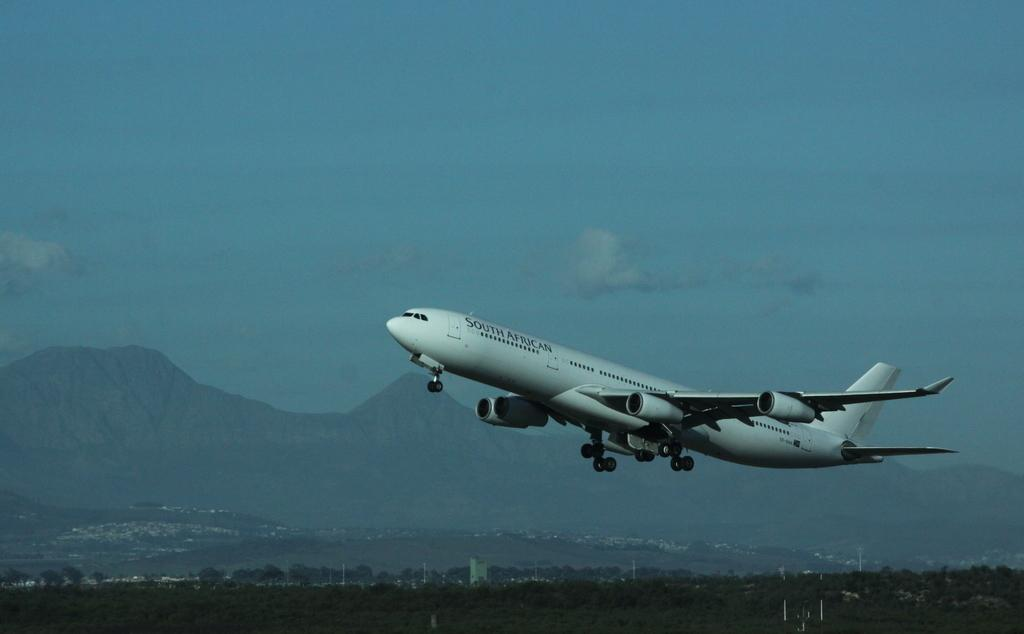What is the main subject of the image? The main subject of the image is an airplane flying. What can be seen at the bottom of the image? There are trees visible at the bottom of the image. What is in the background of the image? There are mountains and the sky visible in the background of the image. How many cherries are hanging from the trees in the image? There are no cherries visible in the image; only trees can be seen at the bottom. What type of boot is being worn by the airplane pilot in the image? There is no pilot or boot present in the image; it only features an airplane flying. 